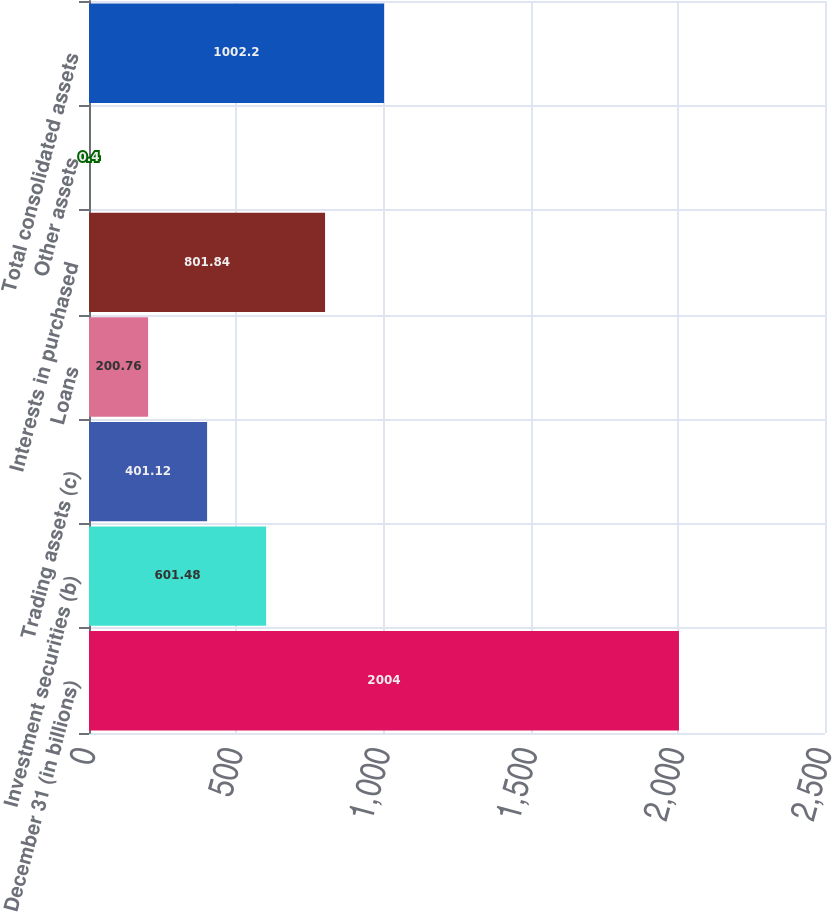Convert chart. <chart><loc_0><loc_0><loc_500><loc_500><bar_chart><fcel>December 31 (in billions)<fcel>Investment securities (b)<fcel>Trading assets (c)<fcel>Loans<fcel>Interests in purchased<fcel>Other assets<fcel>Total consolidated assets<nl><fcel>2004<fcel>601.48<fcel>401.12<fcel>200.76<fcel>801.84<fcel>0.4<fcel>1002.2<nl></chart> 